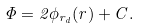<formula> <loc_0><loc_0><loc_500><loc_500>\Phi = 2 \phi _ { { r } _ { d } } ( { r } ) + C .</formula> 